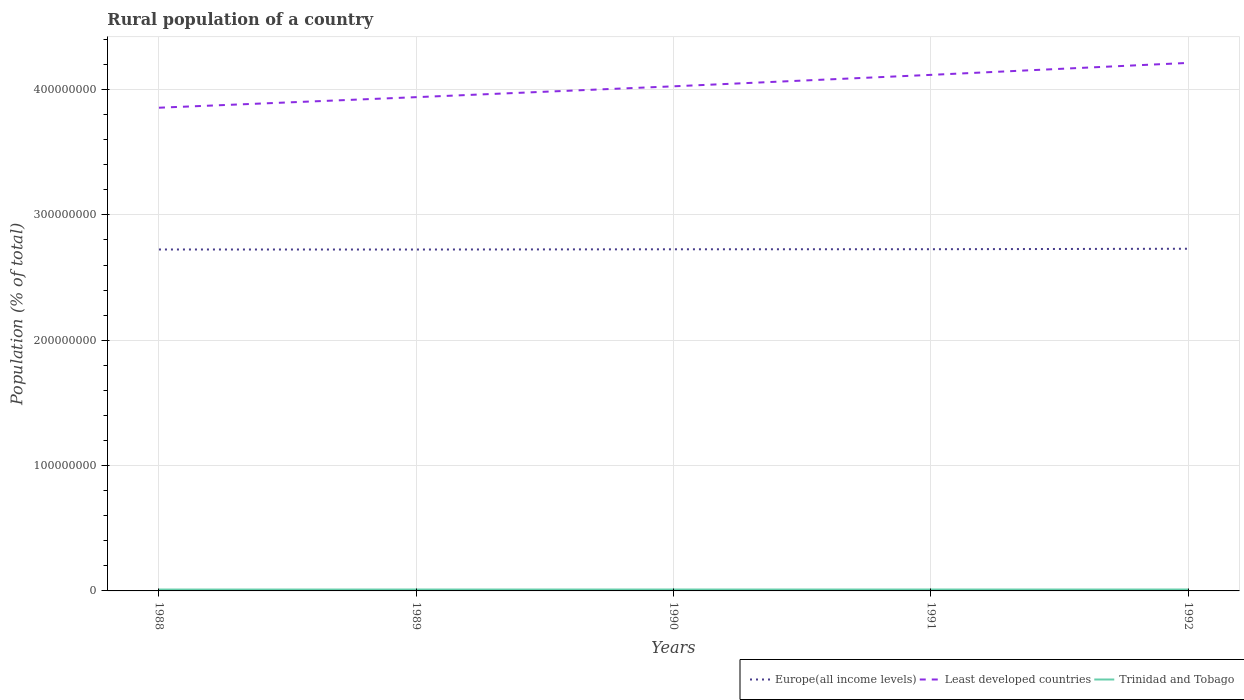How many different coloured lines are there?
Make the answer very short. 3. Does the line corresponding to Trinidad and Tobago intersect with the line corresponding to Least developed countries?
Offer a terse response. No. Is the number of lines equal to the number of legend labels?
Your answer should be compact. Yes. Across all years, what is the maximum rural population in Europe(all income levels)?
Offer a terse response. 2.72e+08. What is the total rural population in Trinidad and Tobago in the graph?
Offer a very short reply. -2.90e+04. What is the difference between the highest and the second highest rural population in Europe(all income levels)?
Offer a very short reply. 6.19e+05. How many lines are there?
Make the answer very short. 3. How many years are there in the graph?
Keep it short and to the point. 5. What is the difference between two consecutive major ticks on the Y-axis?
Give a very brief answer. 1.00e+08. Are the values on the major ticks of Y-axis written in scientific E-notation?
Offer a very short reply. No. Does the graph contain grids?
Give a very brief answer. Yes. Where does the legend appear in the graph?
Your answer should be compact. Bottom right. How many legend labels are there?
Ensure brevity in your answer.  3. What is the title of the graph?
Provide a short and direct response. Rural population of a country. Does "Jordan" appear as one of the legend labels in the graph?
Provide a succinct answer. No. What is the label or title of the X-axis?
Provide a short and direct response. Years. What is the label or title of the Y-axis?
Make the answer very short. Population (% of total). What is the Population (% of total) of Europe(all income levels) in 1988?
Keep it short and to the point. 2.72e+08. What is the Population (% of total) in Least developed countries in 1988?
Provide a succinct answer. 3.85e+08. What is the Population (% of total) of Trinidad and Tobago in 1988?
Give a very brief answer. 1.10e+06. What is the Population (% of total) in Europe(all income levels) in 1989?
Offer a terse response. 2.72e+08. What is the Population (% of total) of Least developed countries in 1989?
Provide a succinct answer. 3.94e+08. What is the Population (% of total) of Trinidad and Tobago in 1989?
Give a very brief answer. 1.11e+06. What is the Population (% of total) of Europe(all income levels) in 1990?
Your answer should be very brief. 2.73e+08. What is the Population (% of total) of Least developed countries in 1990?
Offer a terse response. 4.03e+08. What is the Population (% of total) in Trinidad and Tobago in 1990?
Keep it short and to the point. 1.12e+06. What is the Population (% of total) in Europe(all income levels) in 1991?
Your response must be concise. 2.73e+08. What is the Population (% of total) in Least developed countries in 1991?
Offer a terse response. 4.12e+08. What is the Population (% of total) in Trinidad and Tobago in 1991?
Your answer should be very brief. 1.12e+06. What is the Population (% of total) of Europe(all income levels) in 1992?
Provide a short and direct response. 2.73e+08. What is the Population (% of total) in Least developed countries in 1992?
Provide a short and direct response. 4.21e+08. What is the Population (% of total) in Trinidad and Tobago in 1992?
Provide a short and direct response. 1.13e+06. Across all years, what is the maximum Population (% of total) of Europe(all income levels)?
Your answer should be very brief. 2.73e+08. Across all years, what is the maximum Population (% of total) in Least developed countries?
Your answer should be very brief. 4.21e+08. Across all years, what is the maximum Population (% of total) in Trinidad and Tobago?
Provide a short and direct response. 1.13e+06. Across all years, what is the minimum Population (% of total) in Europe(all income levels)?
Your answer should be very brief. 2.72e+08. Across all years, what is the minimum Population (% of total) in Least developed countries?
Keep it short and to the point. 3.85e+08. Across all years, what is the minimum Population (% of total) of Trinidad and Tobago?
Make the answer very short. 1.10e+06. What is the total Population (% of total) of Europe(all income levels) in the graph?
Your response must be concise. 1.36e+09. What is the total Population (% of total) in Least developed countries in the graph?
Your answer should be very brief. 2.01e+09. What is the total Population (% of total) of Trinidad and Tobago in the graph?
Provide a short and direct response. 5.57e+06. What is the difference between the Population (% of total) in Europe(all income levels) in 1988 and that in 1989?
Provide a succinct answer. 3.23e+04. What is the difference between the Population (% of total) in Least developed countries in 1988 and that in 1989?
Give a very brief answer. -8.42e+06. What is the difference between the Population (% of total) in Trinidad and Tobago in 1988 and that in 1989?
Your response must be concise. -1.06e+04. What is the difference between the Population (% of total) in Europe(all income levels) in 1988 and that in 1990?
Provide a short and direct response. -1.55e+05. What is the difference between the Population (% of total) in Least developed countries in 1988 and that in 1990?
Provide a short and direct response. -1.71e+07. What is the difference between the Population (% of total) of Trinidad and Tobago in 1988 and that in 1990?
Offer a terse response. -2.00e+04. What is the difference between the Population (% of total) of Europe(all income levels) in 1988 and that in 1991?
Keep it short and to the point. -2.09e+05. What is the difference between the Population (% of total) of Least developed countries in 1988 and that in 1991?
Give a very brief answer. -2.62e+07. What is the difference between the Population (% of total) of Trinidad and Tobago in 1988 and that in 1991?
Your answer should be very brief. -2.48e+04. What is the difference between the Population (% of total) of Europe(all income levels) in 1988 and that in 1992?
Your answer should be compact. -5.87e+05. What is the difference between the Population (% of total) in Least developed countries in 1988 and that in 1992?
Offer a very short reply. -3.57e+07. What is the difference between the Population (% of total) of Trinidad and Tobago in 1988 and that in 1992?
Offer a very short reply. -2.90e+04. What is the difference between the Population (% of total) of Europe(all income levels) in 1989 and that in 1990?
Offer a terse response. -1.87e+05. What is the difference between the Population (% of total) of Least developed countries in 1989 and that in 1990?
Make the answer very short. -8.65e+06. What is the difference between the Population (% of total) in Trinidad and Tobago in 1989 and that in 1990?
Provide a short and direct response. -9357. What is the difference between the Population (% of total) of Europe(all income levels) in 1989 and that in 1991?
Make the answer very short. -2.41e+05. What is the difference between the Population (% of total) of Least developed countries in 1989 and that in 1991?
Offer a terse response. -1.78e+07. What is the difference between the Population (% of total) in Trinidad and Tobago in 1989 and that in 1991?
Make the answer very short. -1.41e+04. What is the difference between the Population (% of total) of Europe(all income levels) in 1989 and that in 1992?
Offer a very short reply. -6.19e+05. What is the difference between the Population (% of total) of Least developed countries in 1989 and that in 1992?
Offer a terse response. -2.73e+07. What is the difference between the Population (% of total) of Trinidad and Tobago in 1989 and that in 1992?
Your answer should be very brief. -1.84e+04. What is the difference between the Population (% of total) in Europe(all income levels) in 1990 and that in 1991?
Your answer should be compact. -5.40e+04. What is the difference between the Population (% of total) of Least developed countries in 1990 and that in 1991?
Your response must be concise. -9.12e+06. What is the difference between the Population (% of total) in Trinidad and Tobago in 1990 and that in 1991?
Give a very brief answer. -4761. What is the difference between the Population (% of total) in Europe(all income levels) in 1990 and that in 1992?
Your answer should be very brief. -4.32e+05. What is the difference between the Population (% of total) in Least developed countries in 1990 and that in 1992?
Ensure brevity in your answer.  -1.87e+07. What is the difference between the Population (% of total) in Trinidad and Tobago in 1990 and that in 1992?
Provide a succinct answer. -9042. What is the difference between the Population (% of total) in Europe(all income levels) in 1991 and that in 1992?
Ensure brevity in your answer.  -3.78e+05. What is the difference between the Population (% of total) of Least developed countries in 1991 and that in 1992?
Your answer should be very brief. -9.55e+06. What is the difference between the Population (% of total) in Trinidad and Tobago in 1991 and that in 1992?
Provide a short and direct response. -4281. What is the difference between the Population (% of total) of Europe(all income levels) in 1988 and the Population (% of total) of Least developed countries in 1989?
Keep it short and to the point. -1.22e+08. What is the difference between the Population (% of total) of Europe(all income levels) in 1988 and the Population (% of total) of Trinidad and Tobago in 1989?
Keep it short and to the point. 2.71e+08. What is the difference between the Population (% of total) in Least developed countries in 1988 and the Population (% of total) in Trinidad and Tobago in 1989?
Keep it short and to the point. 3.84e+08. What is the difference between the Population (% of total) in Europe(all income levels) in 1988 and the Population (% of total) in Least developed countries in 1990?
Your answer should be compact. -1.30e+08. What is the difference between the Population (% of total) of Europe(all income levels) in 1988 and the Population (% of total) of Trinidad and Tobago in 1990?
Provide a succinct answer. 2.71e+08. What is the difference between the Population (% of total) of Least developed countries in 1988 and the Population (% of total) of Trinidad and Tobago in 1990?
Your answer should be compact. 3.84e+08. What is the difference between the Population (% of total) in Europe(all income levels) in 1988 and the Population (% of total) in Least developed countries in 1991?
Provide a short and direct response. -1.39e+08. What is the difference between the Population (% of total) in Europe(all income levels) in 1988 and the Population (% of total) in Trinidad and Tobago in 1991?
Offer a terse response. 2.71e+08. What is the difference between the Population (% of total) in Least developed countries in 1988 and the Population (% of total) in Trinidad and Tobago in 1991?
Provide a short and direct response. 3.84e+08. What is the difference between the Population (% of total) of Europe(all income levels) in 1988 and the Population (% of total) of Least developed countries in 1992?
Your answer should be compact. -1.49e+08. What is the difference between the Population (% of total) in Europe(all income levels) in 1988 and the Population (% of total) in Trinidad and Tobago in 1992?
Give a very brief answer. 2.71e+08. What is the difference between the Population (% of total) in Least developed countries in 1988 and the Population (% of total) in Trinidad and Tobago in 1992?
Your answer should be very brief. 3.84e+08. What is the difference between the Population (% of total) in Europe(all income levels) in 1989 and the Population (% of total) in Least developed countries in 1990?
Offer a terse response. -1.30e+08. What is the difference between the Population (% of total) in Europe(all income levels) in 1989 and the Population (% of total) in Trinidad and Tobago in 1990?
Give a very brief answer. 2.71e+08. What is the difference between the Population (% of total) of Least developed countries in 1989 and the Population (% of total) of Trinidad and Tobago in 1990?
Offer a very short reply. 3.93e+08. What is the difference between the Population (% of total) in Europe(all income levels) in 1989 and the Population (% of total) in Least developed countries in 1991?
Offer a terse response. -1.39e+08. What is the difference between the Population (% of total) of Europe(all income levels) in 1989 and the Population (% of total) of Trinidad and Tobago in 1991?
Make the answer very short. 2.71e+08. What is the difference between the Population (% of total) in Least developed countries in 1989 and the Population (% of total) in Trinidad and Tobago in 1991?
Your response must be concise. 3.93e+08. What is the difference between the Population (% of total) in Europe(all income levels) in 1989 and the Population (% of total) in Least developed countries in 1992?
Your answer should be very brief. -1.49e+08. What is the difference between the Population (% of total) of Europe(all income levels) in 1989 and the Population (% of total) of Trinidad and Tobago in 1992?
Provide a succinct answer. 2.71e+08. What is the difference between the Population (% of total) of Least developed countries in 1989 and the Population (% of total) of Trinidad and Tobago in 1992?
Provide a short and direct response. 3.93e+08. What is the difference between the Population (% of total) in Europe(all income levels) in 1990 and the Population (% of total) in Least developed countries in 1991?
Offer a very short reply. -1.39e+08. What is the difference between the Population (% of total) of Europe(all income levels) in 1990 and the Population (% of total) of Trinidad and Tobago in 1991?
Your response must be concise. 2.71e+08. What is the difference between the Population (% of total) of Least developed countries in 1990 and the Population (% of total) of Trinidad and Tobago in 1991?
Your answer should be very brief. 4.01e+08. What is the difference between the Population (% of total) of Europe(all income levels) in 1990 and the Population (% of total) of Least developed countries in 1992?
Keep it short and to the point. -1.49e+08. What is the difference between the Population (% of total) of Europe(all income levels) in 1990 and the Population (% of total) of Trinidad and Tobago in 1992?
Your response must be concise. 2.71e+08. What is the difference between the Population (% of total) in Least developed countries in 1990 and the Population (% of total) in Trinidad and Tobago in 1992?
Offer a very short reply. 4.01e+08. What is the difference between the Population (% of total) of Europe(all income levels) in 1991 and the Population (% of total) of Least developed countries in 1992?
Provide a short and direct response. -1.49e+08. What is the difference between the Population (% of total) of Europe(all income levels) in 1991 and the Population (% of total) of Trinidad and Tobago in 1992?
Provide a short and direct response. 2.71e+08. What is the difference between the Population (% of total) in Least developed countries in 1991 and the Population (% of total) in Trinidad and Tobago in 1992?
Provide a short and direct response. 4.11e+08. What is the average Population (% of total) in Europe(all income levels) per year?
Ensure brevity in your answer.  2.73e+08. What is the average Population (% of total) in Least developed countries per year?
Offer a terse response. 4.03e+08. What is the average Population (% of total) in Trinidad and Tobago per year?
Keep it short and to the point. 1.11e+06. In the year 1988, what is the difference between the Population (% of total) of Europe(all income levels) and Population (% of total) of Least developed countries?
Provide a succinct answer. -1.13e+08. In the year 1988, what is the difference between the Population (% of total) in Europe(all income levels) and Population (% of total) in Trinidad and Tobago?
Ensure brevity in your answer.  2.71e+08. In the year 1988, what is the difference between the Population (% of total) of Least developed countries and Population (% of total) of Trinidad and Tobago?
Provide a short and direct response. 3.84e+08. In the year 1989, what is the difference between the Population (% of total) in Europe(all income levels) and Population (% of total) in Least developed countries?
Offer a terse response. -1.22e+08. In the year 1989, what is the difference between the Population (% of total) of Europe(all income levels) and Population (% of total) of Trinidad and Tobago?
Provide a succinct answer. 2.71e+08. In the year 1989, what is the difference between the Population (% of total) in Least developed countries and Population (% of total) in Trinidad and Tobago?
Your response must be concise. 3.93e+08. In the year 1990, what is the difference between the Population (% of total) of Europe(all income levels) and Population (% of total) of Least developed countries?
Offer a terse response. -1.30e+08. In the year 1990, what is the difference between the Population (% of total) of Europe(all income levels) and Population (% of total) of Trinidad and Tobago?
Provide a succinct answer. 2.71e+08. In the year 1990, what is the difference between the Population (% of total) in Least developed countries and Population (% of total) in Trinidad and Tobago?
Provide a short and direct response. 4.01e+08. In the year 1991, what is the difference between the Population (% of total) in Europe(all income levels) and Population (% of total) in Least developed countries?
Your answer should be very brief. -1.39e+08. In the year 1991, what is the difference between the Population (% of total) in Europe(all income levels) and Population (% of total) in Trinidad and Tobago?
Ensure brevity in your answer.  2.71e+08. In the year 1991, what is the difference between the Population (% of total) of Least developed countries and Population (% of total) of Trinidad and Tobago?
Ensure brevity in your answer.  4.11e+08. In the year 1992, what is the difference between the Population (% of total) of Europe(all income levels) and Population (% of total) of Least developed countries?
Offer a very short reply. -1.48e+08. In the year 1992, what is the difference between the Population (% of total) of Europe(all income levels) and Population (% of total) of Trinidad and Tobago?
Make the answer very short. 2.72e+08. In the year 1992, what is the difference between the Population (% of total) in Least developed countries and Population (% of total) in Trinidad and Tobago?
Keep it short and to the point. 4.20e+08. What is the ratio of the Population (% of total) in Least developed countries in 1988 to that in 1989?
Provide a short and direct response. 0.98. What is the ratio of the Population (% of total) of Trinidad and Tobago in 1988 to that in 1989?
Make the answer very short. 0.99. What is the ratio of the Population (% of total) of Least developed countries in 1988 to that in 1990?
Provide a short and direct response. 0.96. What is the ratio of the Population (% of total) of Trinidad and Tobago in 1988 to that in 1990?
Keep it short and to the point. 0.98. What is the ratio of the Population (% of total) in Least developed countries in 1988 to that in 1991?
Your response must be concise. 0.94. What is the ratio of the Population (% of total) in Trinidad and Tobago in 1988 to that in 1991?
Offer a terse response. 0.98. What is the ratio of the Population (% of total) in Europe(all income levels) in 1988 to that in 1992?
Provide a succinct answer. 1. What is the ratio of the Population (% of total) in Least developed countries in 1988 to that in 1992?
Keep it short and to the point. 0.92. What is the ratio of the Population (% of total) in Trinidad and Tobago in 1988 to that in 1992?
Your answer should be very brief. 0.97. What is the ratio of the Population (% of total) in Least developed countries in 1989 to that in 1990?
Make the answer very short. 0.98. What is the ratio of the Population (% of total) of Europe(all income levels) in 1989 to that in 1991?
Provide a succinct answer. 1. What is the ratio of the Population (% of total) of Least developed countries in 1989 to that in 1991?
Provide a short and direct response. 0.96. What is the ratio of the Population (% of total) of Trinidad and Tobago in 1989 to that in 1991?
Offer a very short reply. 0.99. What is the ratio of the Population (% of total) in Europe(all income levels) in 1989 to that in 1992?
Give a very brief answer. 1. What is the ratio of the Population (% of total) of Least developed countries in 1989 to that in 1992?
Give a very brief answer. 0.94. What is the ratio of the Population (% of total) in Trinidad and Tobago in 1989 to that in 1992?
Your answer should be very brief. 0.98. What is the ratio of the Population (% of total) in Europe(all income levels) in 1990 to that in 1991?
Give a very brief answer. 1. What is the ratio of the Population (% of total) in Least developed countries in 1990 to that in 1991?
Your answer should be compact. 0.98. What is the ratio of the Population (% of total) in Least developed countries in 1990 to that in 1992?
Your answer should be compact. 0.96. What is the ratio of the Population (% of total) of Least developed countries in 1991 to that in 1992?
Your answer should be compact. 0.98. What is the difference between the highest and the second highest Population (% of total) of Europe(all income levels)?
Provide a succinct answer. 3.78e+05. What is the difference between the highest and the second highest Population (% of total) of Least developed countries?
Offer a terse response. 9.55e+06. What is the difference between the highest and the second highest Population (% of total) in Trinidad and Tobago?
Offer a terse response. 4281. What is the difference between the highest and the lowest Population (% of total) in Europe(all income levels)?
Ensure brevity in your answer.  6.19e+05. What is the difference between the highest and the lowest Population (% of total) of Least developed countries?
Make the answer very short. 3.57e+07. What is the difference between the highest and the lowest Population (% of total) of Trinidad and Tobago?
Offer a very short reply. 2.90e+04. 